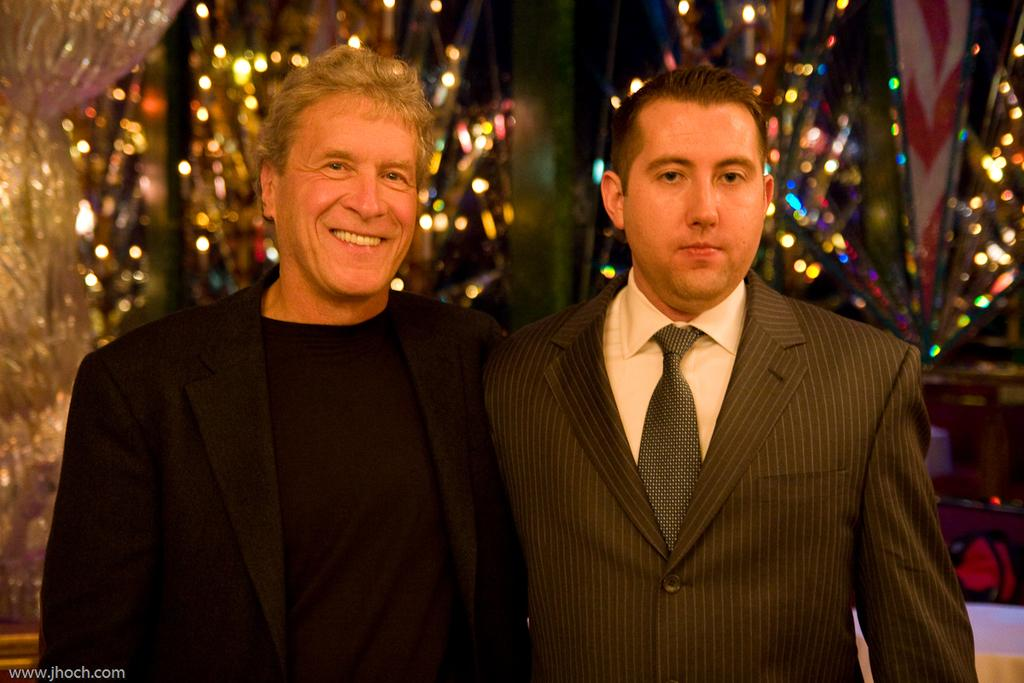How many men are present in the image? There are two men in the image. Can you describe the facial expression of one of the men? One of the men is smiling. What type of clothing are the men wearing in the image? Both men are wearing coats. What can be seen in the background of the image? There are lights and curtains in the background of the image. Can you tell me how many kitties are sitting on the men's feet in the image? There are no kitties present in the image, and therefore no kitties can be seen sitting on the men's feet. 